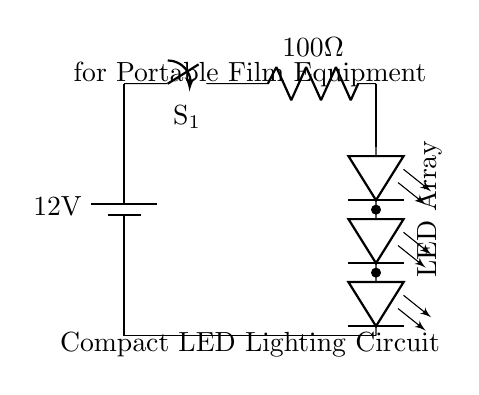What is the voltage of the power source? The voltage of the power source is given as 12V, indicated by the battery symbol in the circuit diagram.
Answer: 12 volts What is the resistance value in this circuit? The resistance value is specified as 100 Ohms, which is marked next to the resistor symbol in the diagram.
Answer: 100 Ohms How many LEDs are in the array? The LED array consists of four LEDs, as indicated by the vertical arrangement of LED symbols in the circuit diagram.
Answer: Four What is the function of the switch in this circuit? The switch functions to open or close the circuit, thereby controlling the flow of current to the LED array. When open, the circuit is incomplete and the LEDs do not light up. When closed, the circuit is complete, allowing the current to flow.
Answer: Control current What happens to the current passing through the circuit when the switch is closed? When the switch is closed, the current flows from the battery through the switch, through the resistor (which limits the current), and then through the LED array. The resistor's role is to protect the LEDs from receiving too much current, preventing damage. Thus, the current flowing will be regulated based on the resistor value.
Answer: Current flows What is the purpose of the current limiting resistor in this circuit? The current-limiting resistor is used to prevent excessive current from flowing through the LED array. It ensures that the LEDs receive a safe amount of current, which is essential for their longevity and proper functioning. Without it, the LEDs could be damaged due to increased current.
Answer: Protect LEDs 